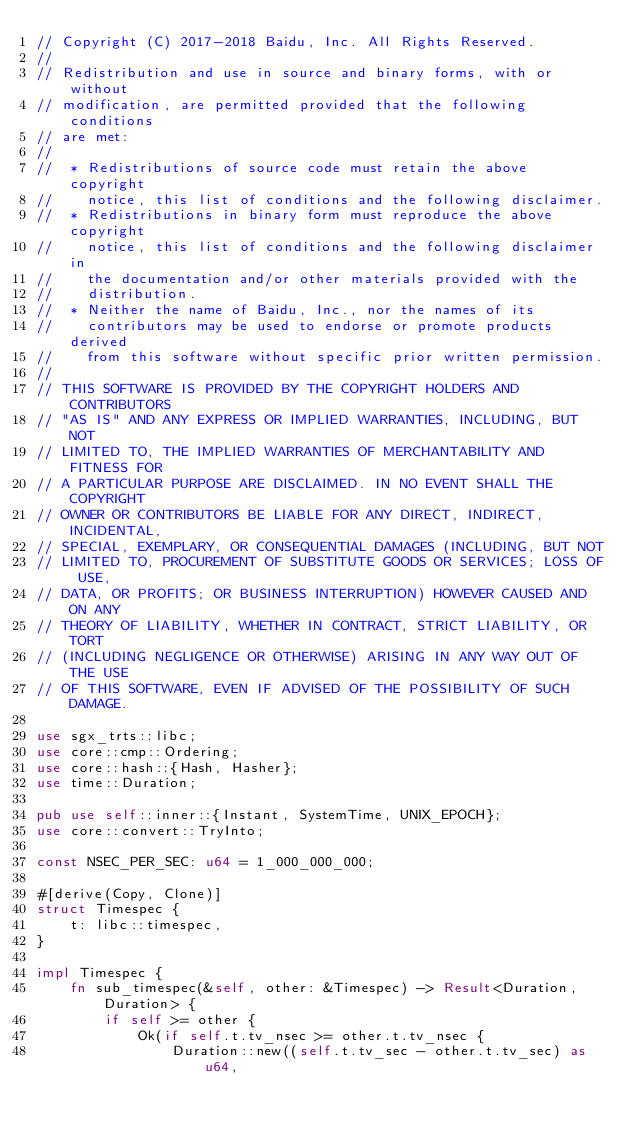Convert code to text. <code><loc_0><loc_0><loc_500><loc_500><_Rust_>// Copyright (C) 2017-2018 Baidu, Inc. All Rights Reserved.
//
// Redistribution and use in source and binary forms, with or without
// modification, are permitted provided that the following conditions
// are met:
//
//  * Redistributions of source code must retain the above copyright
//    notice, this list of conditions and the following disclaimer.
//  * Redistributions in binary form must reproduce the above copyright
//    notice, this list of conditions and the following disclaimer in
//    the documentation and/or other materials provided with the
//    distribution.
//  * Neither the name of Baidu, Inc., nor the names of its
//    contributors may be used to endorse or promote products derived
//    from this software without specific prior written permission.
//
// THIS SOFTWARE IS PROVIDED BY THE COPYRIGHT HOLDERS AND CONTRIBUTORS
// "AS IS" AND ANY EXPRESS OR IMPLIED WARRANTIES, INCLUDING, BUT NOT
// LIMITED TO, THE IMPLIED WARRANTIES OF MERCHANTABILITY AND FITNESS FOR
// A PARTICULAR PURPOSE ARE DISCLAIMED. IN NO EVENT SHALL THE COPYRIGHT
// OWNER OR CONTRIBUTORS BE LIABLE FOR ANY DIRECT, INDIRECT, INCIDENTAL,
// SPECIAL, EXEMPLARY, OR CONSEQUENTIAL DAMAGES (INCLUDING, BUT NOT
// LIMITED TO, PROCUREMENT OF SUBSTITUTE GOODS OR SERVICES; LOSS OF USE,
// DATA, OR PROFITS; OR BUSINESS INTERRUPTION) HOWEVER CAUSED AND ON ANY
// THEORY OF LIABILITY, WHETHER IN CONTRACT, STRICT LIABILITY, OR TORT
// (INCLUDING NEGLIGENCE OR OTHERWISE) ARISING IN ANY WAY OUT OF THE USE
// OF THIS SOFTWARE, EVEN IF ADVISED OF THE POSSIBILITY OF SUCH DAMAGE.

use sgx_trts::libc;
use core::cmp::Ordering;
use core::hash::{Hash, Hasher};
use time::Duration;

pub use self::inner::{Instant, SystemTime, UNIX_EPOCH};
use core::convert::TryInto;

const NSEC_PER_SEC: u64 = 1_000_000_000;

#[derive(Copy, Clone)]
struct Timespec {
    t: libc::timespec,
}

impl Timespec {
    fn sub_timespec(&self, other: &Timespec) -> Result<Duration, Duration> {
        if self >= other {
            Ok(if self.t.tv_nsec >= other.t.tv_nsec {
                Duration::new((self.t.tv_sec - other.t.tv_sec) as u64,</code> 